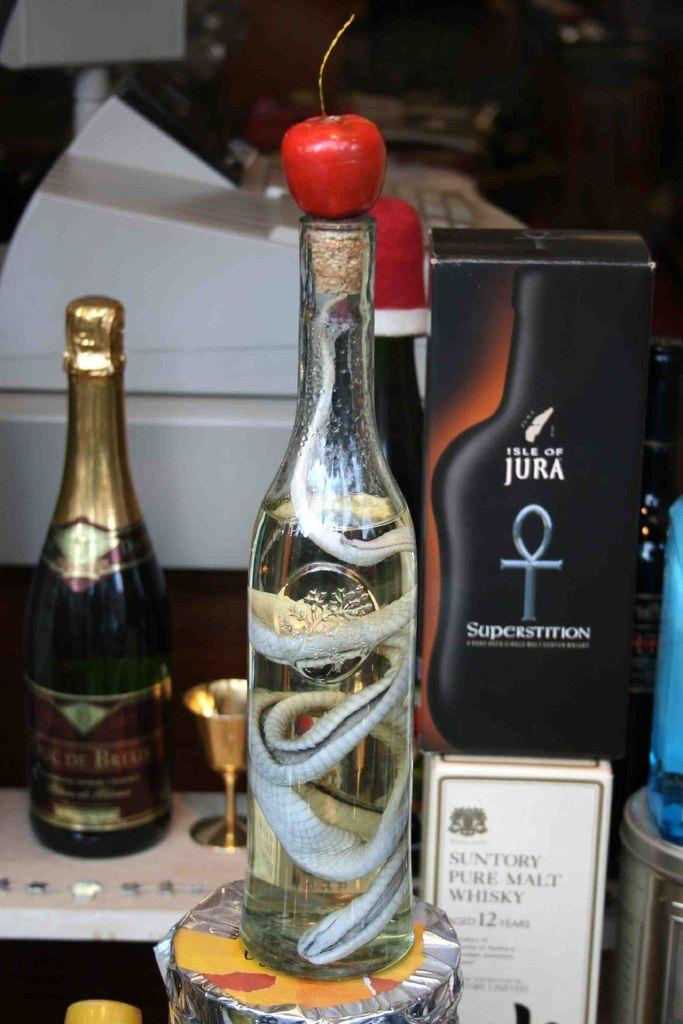<image>
Render a clear and concise summary of the photo. A black box from Isle of Jura sits behind a bottle featuring a snake with an apple on top. 